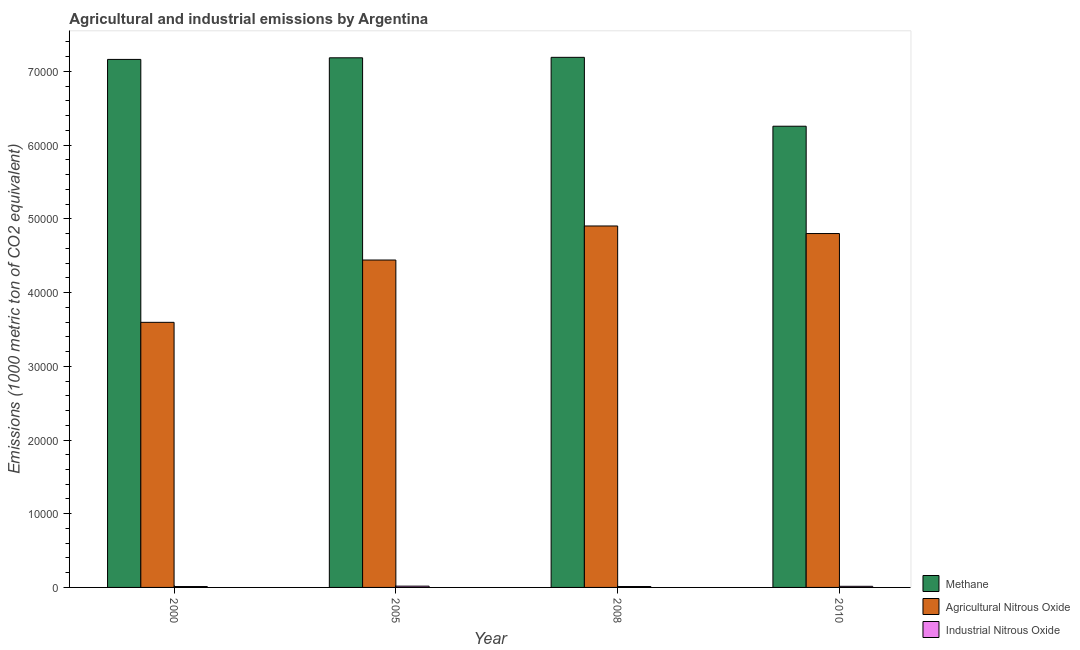How many groups of bars are there?
Your response must be concise. 4. Are the number of bars on each tick of the X-axis equal?
Your answer should be very brief. Yes. How many bars are there on the 3rd tick from the left?
Your answer should be very brief. 3. How many bars are there on the 2nd tick from the right?
Your answer should be compact. 3. In how many cases, is the number of bars for a given year not equal to the number of legend labels?
Provide a short and direct response. 0. What is the amount of methane emissions in 2008?
Make the answer very short. 7.19e+04. Across all years, what is the maximum amount of methane emissions?
Give a very brief answer. 7.19e+04. Across all years, what is the minimum amount of industrial nitrous oxide emissions?
Offer a terse response. 120. In which year was the amount of industrial nitrous oxide emissions maximum?
Your answer should be compact. 2005. What is the total amount of industrial nitrous oxide emissions in the graph?
Provide a short and direct response. 569.2. What is the difference between the amount of methane emissions in 2008 and that in 2010?
Your answer should be compact. 9345.8. What is the difference between the amount of agricultural nitrous oxide emissions in 2000 and the amount of methane emissions in 2005?
Give a very brief answer. -8453.1. What is the average amount of methane emissions per year?
Your answer should be very brief. 6.95e+04. In the year 2000, what is the difference between the amount of methane emissions and amount of industrial nitrous oxide emissions?
Keep it short and to the point. 0. In how many years, is the amount of methane emissions greater than 56000 metric ton?
Your answer should be very brief. 4. What is the ratio of the amount of methane emissions in 2000 to that in 2005?
Your response must be concise. 1. Is the amount of industrial nitrous oxide emissions in 2008 less than that in 2010?
Ensure brevity in your answer.  Yes. What is the difference between the highest and the second highest amount of agricultural nitrous oxide emissions?
Provide a short and direct response. 1026. What is the difference between the highest and the lowest amount of methane emissions?
Ensure brevity in your answer.  9345.8. In how many years, is the amount of industrial nitrous oxide emissions greater than the average amount of industrial nitrous oxide emissions taken over all years?
Make the answer very short. 2. Is the sum of the amount of agricultural nitrous oxide emissions in 2000 and 2010 greater than the maximum amount of industrial nitrous oxide emissions across all years?
Provide a succinct answer. Yes. What does the 1st bar from the left in 2000 represents?
Your answer should be compact. Methane. What does the 3rd bar from the right in 2008 represents?
Give a very brief answer. Methane. What is the difference between two consecutive major ticks on the Y-axis?
Provide a succinct answer. 10000. Are the values on the major ticks of Y-axis written in scientific E-notation?
Ensure brevity in your answer.  No. Does the graph contain grids?
Give a very brief answer. No. How many legend labels are there?
Ensure brevity in your answer.  3. What is the title of the graph?
Offer a terse response. Agricultural and industrial emissions by Argentina. Does "Oil" appear as one of the legend labels in the graph?
Your response must be concise. No. What is the label or title of the Y-axis?
Your response must be concise. Emissions (1000 metric ton of CO2 equivalent). What is the Emissions (1000 metric ton of CO2 equivalent) of Methane in 2000?
Ensure brevity in your answer.  7.16e+04. What is the Emissions (1000 metric ton of CO2 equivalent) of Agricultural Nitrous Oxide in 2000?
Offer a very short reply. 3.60e+04. What is the Emissions (1000 metric ton of CO2 equivalent) in Industrial Nitrous Oxide in 2000?
Your response must be concise. 120. What is the Emissions (1000 metric ton of CO2 equivalent) of Methane in 2005?
Keep it short and to the point. 7.19e+04. What is the Emissions (1000 metric ton of CO2 equivalent) of Agricultural Nitrous Oxide in 2005?
Offer a very short reply. 4.44e+04. What is the Emissions (1000 metric ton of CO2 equivalent) of Industrial Nitrous Oxide in 2005?
Ensure brevity in your answer.  174.4. What is the Emissions (1000 metric ton of CO2 equivalent) of Methane in 2008?
Your answer should be compact. 7.19e+04. What is the Emissions (1000 metric ton of CO2 equivalent) in Agricultural Nitrous Oxide in 2008?
Keep it short and to the point. 4.90e+04. What is the Emissions (1000 metric ton of CO2 equivalent) in Industrial Nitrous Oxide in 2008?
Keep it short and to the point. 123. What is the Emissions (1000 metric ton of CO2 equivalent) in Methane in 2010?
Make the answer very short. 6.26e+04. What is the Emissions (1000 metric ton of CO2 equivalent) of Agricultural Nitrous Oxide in 2010?
Offer a very short reply. 4.80e+04. What is the Emissions (1000 metric ton of CO2 equivalent) in Industrial Nitrous Oxide in 2010?
Provide a succinct answer. 151.8. Across all years, what is the maximum Emissions (1000 metric ton of CO2 equivalent) in Methane?
Your answer should be very brief. 7.19e+04. Across all years, what is the maximum Emissions (1000 metric ton of CO2 equivalent) of Agricultural Nitrous Oxide?
Your answer should be very brief. 4.90e+04. Across all years, what is the maximum Emissions (1000 metric ton of CO2 equivalent) in Industrial Nitrous Oxide?
Offer a very short reply. 174.4. Across all years, what is the minimum Emissions (1000 metric ton of CO2 equivalent) in Methane?
Provide a succinct answer. 6.26e+04. Across all years, what is the minimum Emissions (1000 metric ton of CO2 equivalent) of Agricultural Nitrous Oxide?
Your response must be concise. 3.60e+04. Across all years, what is the minimum Emissions (1000 metric ton of CO2 equivalent) of Industrial Nitrous Oxide?
Your answer should be very brief. 120. What is the total Emissions (1000 metric ton of CO2 equivalent) of Methane in the graph?
Your answer should be compact. 2.78e+05. What is the total Emissions (1000 metric ton of CO2 equivalent) of Agricultural Nitrous Oxide in the graph?
Provide a short and direct response. 1.77e+05. What is the total Emissions (1000 metric ton of CO2 equivalent) in Industrial Nitrous Oxide in the graph?
Provide a succinct answer. 569.2. What is the difference between the Emissions (1000 metric ton of CO2 equivalent) of Methane in 2000 and that in 2005?
Your answer should be compact. -219. What is the difference between the Emissions (1000 metric ton of CO2 equivalent) of Agricultural Nitrous Oxide in 2000 and that in 2005?
Give a very brief answer. -8453.1. What is the difference between the Emissions (1000 metric ton of CO2 equivalent) in Industrial Nitrous Oxide in 2000 and that in 2005?
Make the answer very short. -54.4. What is the difference between the Emissions (1000 metric ton of CO2 equivalent) of Methane in 2000 and that in 2008?
Keep it short and to the point. -283.1. What is the difference between the Emissions (1000 metric ton of CO2 equivalent) in Agricultural Nitrous Oxide in 2000 and that in 2008?
Offer a terse response. -1.31e+04. What is the difference between the Emissions (1000 metric ton of CO2 equivalent) of Methane in 2000 and that in 2010?
Your response must be concise. 9062.7. What is the difference between the Emissions (1000 metric ton of CO2 equivalent) in Agricultural Nitrous Oxide in 2000 and that in 2010?
Give a very brief answer. -1.20e+04. What is the difference between the Emissions (1000 metric ton of CO2 equivalent) of Industrial Nitrous Oxide in 2000 and that in 2010?
Your answer should be very brief. -31.8. What is the difference between the Emissions (1000 metric ton of CO2 equivalent) in Methane in 2005 and that in 2008?
Your answer should be compact. -64.1. What is the difference between the Emissions (1000 metric ton of CO2 equivalent) in Agricultural Nitrous Oxide in 2005 and that in 2008?
Your response must be concise. -4617.7. What is the difference between the Emissions (1000 metric ton of CO2 equivalent) of Industrial Nitrous Oxide in 2005 and that in 2008?
Your answer should be compact. 51.4. What is the difference between the Emissions (1000 metric ton of CO2 equivalent) in Methane in 2005 and that in 2010?
Ensure brevity in your answer.  9281.7. What is the difference between the Emissions (1000 metric ton of CO2 equivalent) of Agricultural Nitrous Oxide in 2005 and that in 2010?
Provide a short and direct response. -3591.7. What is the difference between the Emissions (1000 metric ton of CO2 equivalent) of Industrial Nitrous Oxide in 2005 and that in 2010?
Make the answer very short. 22.6. What is the difference between the Emissions (1000 metric ton of CO2 equivalent) in Methane in 2008 and that in 2010?
Provide a short and direct response. 9345.8. What is the difference between the Emissions (1000 metric ton of CO2 equivalent) of Agricultural Nitrous Oxide in 2008 and that in 2010?
Offer a terse response. 1026. What is the difference between the Emissions (1000 metric ton of CO2 equivalent) in Industrial Nitrous Oxide in 2008 and that in 2010?
Your answer should be very brief. -28.8. What is the difference between the Emissions (1000 metric ton of CO2 equivalent) of Methane in 2000 and the Emissions (1000 metric ton of CO2 equivalent) of Agricultural Nitrous Oxide in 2005?
Give a very brief answer. 2.72e+04. What is the difference between the Emissions (1000 metric ton of CO2 equivalent) in Methane in 2000 and the Emissions (1000 metric ton of CO2 equivalent) in Industrial Nitrous Oxide in 2005?
Offer a terse response. 7.15e+04. What is the difference between the Emissions (1000 metric ton of CO2 equivalent) in Agricultural Nitrous Oxide in 2000 and the Emissions (1000 metric ton of CO2 equivalent) in Industrial Nitrous Oxide in 2005?
Ensure brevity in your answer.  3.58e+04. What is the difference between the Emissions (1000 metric ton of CO2 equivalent) of Methane in 2000 and the Emissions (1000 metric ton of CO2 equivalent) of Agricultural Nitrous Oxide in 2008?
Offer a very short reply. 2.26e+04. What is the difference between the Emissions (1000 metric ton of CO2 equivalent) in Methane in 2000 and the Emissions (1000 metric ton of CO2 equivalent) in Industrial Nitrous Oxide in 2008?
Offer a terse response. 7.15e+04. What is the difference between the Emissions (1000 metric ton of CO2 equivalent) of Agricultural Nitrous Oxide in 2000 and the Emissions (1000 metric ton of CO2 equivalent) of Industrial Nitrous Oxide in 2008?
Your answer should be compact. 3.58e+04. What is the difference between the Emissions (1000 metric ton of CO2 equivalent) of Methane in 2000 and the Emissions (1000 metric ton of CO2 equivalent) of Agricultural Nitrous Oxide in 2010?
Provide a succinct answer. 2.36e+04. What is the difference between the Emissions (1000 metric ton of CO2 equivalent) of Methane in 2000 and the Emissions (1000 metric ton of CO2 equivalent) of Industrial Nitrous Oxide in 2010?
Your answer should be compact. 7.15e+04. What is the difference between the Emissions (1000 metric ton of CO2 equivalent) of Agricultural Nitrous Oxide in 2000 and the Emissions (1000 metric ton of CO2 equivalent) of Industrial Nitrous Oxide in 2010?
Provide a short and direct response. 3.58e+04. What is the difference between the Emissions (1000 metric ton of CO2 equivalent) in Methane in 2005 and the Emissions (1000 metric ton of CO2 equivalent) in Agricultural Nitrous Oxide in 2008?
Keep it short and to the point. 2.28e+04. What is the difference between the Emissions (1000 metric ton of CO2 equivalent) of Methane in 2005 and the Emissions (1000 metric ton of CO2 equivalent) of Industrial Nitrous Oxide in 2008?
Give a very brief answer. 7.17e+04. What is the difference between the Emissions (1000 metric ton of CO2 equivalent) of Agricultural Nitrous Oxide in 2005 and the Emissions (1000 metric ton of CO2 equivalent) of Industrial Nitrous Oxide in 2008?
Your answer should be compact. 4.43e+04. What is the difference between the Emissions (1000 metric ton of CO2 equivalent) in Methane in 2005 and the Emissions (1000 metric ton of CO2 equivalent) in Agricultural Nitrous Oxide in 2010?
Provide a short and direct response. 2.38e+04. What is the difference between the Emissions (1000 metric ton of CO2 equivalent) in Methane in 2005 and the Emissions (1000 metric ton of CO2 equivalent) in Industrial Nitrous Oxide in 2010?
Your answer should be compact. 7.17e+04. What is the difference between the Emissions (1000 metric ton of CO2 equivalent) in Agricultural Nitrous Oxide in 2005 and the Emissions (1000 metric ton of CO2 equivalent) in Industrial Nitrous Oxide in 2010?
Make the answer very short. 4.43e+04. What is the difference between the Emissions (1000 metric ton of CO2 equivalent) of Methane in 2008 and the Emissions (1000 metric ton of CO2 equivalent) of Agricultural Nitrous Oxide in 2010?
Ensure brevity in your answer.  2.39e+04. What is the difference between the Emissions (1000 metric ton of CO2 equivalent) in Methane in 2008 and the Emissions (1000 metric ton of CO2 equivalent) in Industrial Nitrous Oxide in 2010?
Your answer should be compact. 7.18e+04. What is the difference between the Emissions (1000 metric ton of CO2 equivalent) in Agricultural Nitrous Oxide in 2008 and the Emissions (1000 metric ton of CO2 equivalent) in Industrial Nitrous Oxide in 2010?
Keep it short and to the point. 4.89e+04. What is the average Emissions (1000 metric ton of CO2 equivalent) in Methane per year?
Your answer should be very brief. 6.95e+04. What is the average Emissions (1000 metric ton of CO2 equivalent) of Agricultural Nitrous Oxide per year?
Offer a very short reply. 4.44e+04. What is the average Emissions (1000 metric ton of CO2 equivalent) of Industrial Nitrous Oxide per year?
Ensure brevity in your answer.  142.3. In the year 2000, what is the difference between the Emissions (1000 metric ton of CO2 equivalent) of Methane and Emissions (1000 metric ton of CO2 equivalent) of Agricultural Nitrous Oxide?
Ensure brevity in your answer.  3.57e+04. In the year 2000, what is the difference between the Emissions (1000 metric ton of CO2 equivalent) in Methane and Emissions (1000 metric ton of CO2 equivalent) in Industrial Nitrous Oxide?
Keep it short and to the point. 7.15e+04. In the year 2000, what is the difference between the Emissions (1000 metric ton of CO2 equivalent) of Agricultural Nitrous Oxide and Emissions (1000 metric ton of CO2 equivalent) of Industrial Nitrous Oxide?
Keep it short and to the point. 3.58e+04. In the year 2005, what is the difference between the Emissions (1000 metric ton of CO2 equivalent) of Methane and Emissions (1000 metric ton of CO2 equivalent) of Agricultural Nitrous Oxide?
Your answer should be compact. 2.74e+04. In the year 2005, what is the difference between the Emissions (1000 metric ton of CO2 equivalent) of Methane and Emissions (1000 metric ton of CO2 equivalent) of Industrial Nitrous Oxide?
Keep it short and to the point. 7.17e+04. In the year 2005, what is the difference between the Emissions (1000 metric ton of CO2 equivalent) of Agricultural Nitrous Oxide and Emissions (1000 metric ton of CO2 equivalent) of Industrial Nitrous Oxide?
Ensure brevity in your answer.  4.42e+04. In the year 2008, what is the difference between the Emissions (1000 metric ton of CO2 equivalent) in Methane and Emissions (1000 metric ton of CO2 equivalent) in Agricultural Nitrous Oxide?
Provide a succinct answer. 2.29e+04. In the year 2008, what is the difference between the Emissions (1000 metric ton of CO2 equivalent) in Methane and Emissions (1000 metric ton of CO2 equivalent) in Industrial Nitrous Oxide?
Your answer should be very brief. 7.18e+04. In the year 2008, what is the difference between the Emissions (1000 metric ton of CO2 equivalent) in Agricultural Nitrous Oxide and Emissions (1000 metric ton of CO2 equivalent) in Industrial Nitrous Oxide?
Your answer should be very brief. 4.89e+04. In the year 2010, what is the difference between the Emissions (1000 metric ton of CO2 equivalent) in Methane and Emissions (1000 metric ton of CO2 equivalent) in Agricultural Nitrous Oxide?
Ensure brevity in your answer.  1.46e+04. In the year 2010, what is the difference between the Emissions (1000 metric ton of CO2 equivalent) of Methane and Emissions (1000 metric ton of CO2 equivalent) of Industrial Nitrous Oxide?
Offer a terse response. 6.24e+04. In the year 2010, what is the difference between the Emissions (1000 metric ton of CO2 equivalent) in Agricultural Nitrous Oxide and Emissions (1000 metric ton of CO2 equivalent) in Industrial Nitrous Oxide?
Offer a very short reply. 4.79e+04. What is the ratio of the Emissions (1000 metric ton of CO2 equivalent) of Methane in 2000 to that in 2005?
Provide a succinct answer. 1. What is the ratio of the Emissions (1000 metric ton of CO2 equivalent) of Agricultural Nitrous Oxide in 2000 to that in 2005?
Your answer should be very brief. 0.81. What is the ratio of the Emissions (1000 metric ton of CO2 equivalent) in Industrial Nitrous Oxide in 2000 to that in 2005?
Keep it short and to the point. 0.69. What is the ratio of the Emissions (1000 metric ton of CO2 equivalent) of Agricultural Nitrous Oxide in 2000 to that in 2008?
Provide a short and direct response. 0.73. What is the ratio of the Emissions (1000 metric ton of CO2 equivalent) of Industrial Nitrous Oxide in 2000 to that in 2008?
Provide a succinct answer. 0.98. What is the ratio of the Emissions (1000 metric ton of CO2 equivalent) of Methane in 2000 to that in 2010?
Ensure brevity in your answer.  1.14. What is the ratio of the Emissions (1000 metric ton of CO2 equivalent) in Agricultural Nitrous Oxide in 2000 to that in 2010?
Make the answer very short. 0.75. What is the ratio of the Emissions (1000 metric ton of CO2 equivalent) of Industrial Nitrous Oxide in 2000 to that in 2010?
Offer a very short reply. 0.79. What is the ratio of the Emissions (1000 metric ton of CO2 equivalent) in Agricultural Nitrous Oxide in 2005 to that in 2008?
Keep it short and to the point. 0.91. What is the ratio of the Emissions (1000 metric ton of CO2 equivalent) in Industrial Nitrous Oxide in 2005 to that in 2008?
Provide a succinct answer. 1.42. What is the ratio of the Emissions (1000 metric ton of CO2 equivalent) of Methane in 2005 to that in 2010?
Provide a short and direct response. 1.15. What is the ratio of the Emissions (1000 metric ton of CO2 equivalent) in Agricultural Nitrous Oxide in 2005 to that in 2010?
Your answer should be very brief. 0.93. What is the ratio of the Emissions (1000 metric ton of CO2 equivalent) of Industrial Nitrous Oxide in 2005 to that in 2010?
Provide a succinct answer. 1.15. What is the ratio of the Emissions (1000 metric ton of CO2 equivalent) of Methane in 2008 to that in 2010?
Offer a very short reply. 1.15. What is the ratio of the Emissions (1000 metric ton of CO2 equivalent) in Agricultural Nitrous Oxide in 2008 to that in 2010?
Make the answer very short. 1.02. What is the ratio of the Emissions (1000 metric ton of CO2 equivalent) in Industrial Nitrous Oxide in 2008 to that in 2010?
Keep it short and to the point. 0.81. What is the difference between the highest and the second highest Emissions (1000 metric ton of CO2 equivalent) in Methane?
Offer a terse response. 64.1. What is the difference between the highest and the second highest Emissions (1000 metric ton of CO2 equivalent) in Agricultural Nitrous Oxide?
Make the answer very short. 1026. What is the difference between the highest and the second highest Emissions (1000 metric ton of CO2 equivalent) in Industrial Nitrous Oxide?
Your response must be concise. 22.6. What is the difference between the highest and the lowest Emissions (1000 metric ton of CO2 equivalent) in Methane?
Provide a succinct answer. 9345.8. What is the difference between the highest and the lowest Emissions (1000 metric ton of CO2 equivalent) of Agricultural Nitrous Oxide?
Offer a terse response. 1.31e+04. What is the difference between the highest and the lowest Emissions (1000 metric ton of CO2 equivalent) in Industrial Nitrous Oxide?
Offer a terse response. 54.4. 